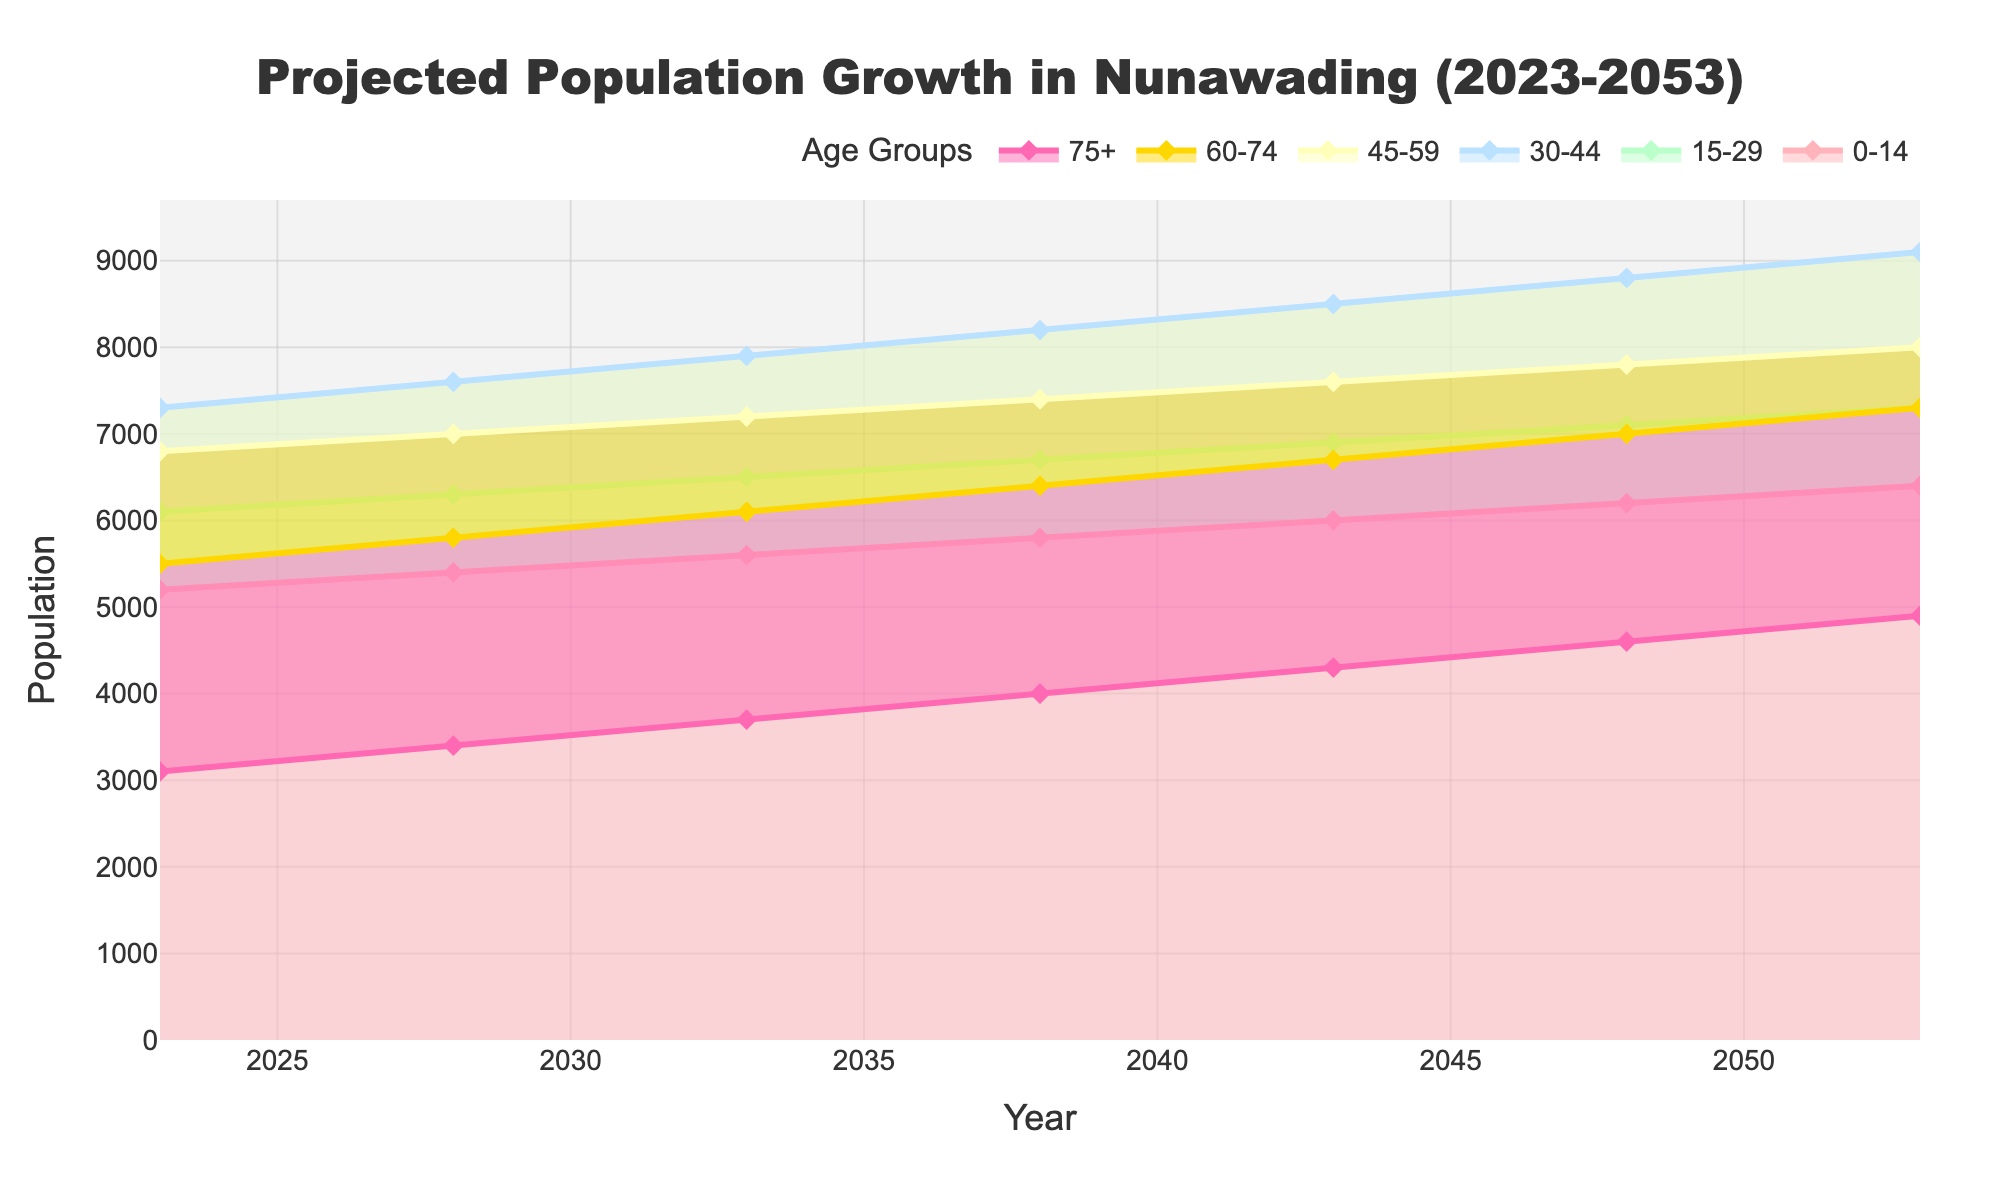What is the title of the chart? The title is displayed prominently at the top center of the chart. It describes the purpose and scope of the data presented.
Answer: Projected Population Growth in Nunawading (2023-2053) How many age groups are represented in the chart? The chart legend lists each age group, and there are six distinct colors used in the chart, each corresponding to a different age group.
Answer: 6 Which age group has the smallest population projected in 2023? By looking at the starting values at the leftmost part of the chart in 2023, the age group "75+" has the smallest population, as represented by the lowest line.
Answer: 75+ What is the projected population of the 30-44 age group in 2038? Find the data point on the curve for the 30-44 age group at the year 2038, which is situated on the x-axis.
Answer: 8200 How does the population of the 0-14 age group change from 2023 to 2053? Subtract the value at 2023 from the value at 2053 for the 0-14 age group to find the difference.
Answer: Increase of 1200 Which age group shows the highest growth rate between 2023 and 2053? Compare the difference between 2053 and 2023 values for all age groups and find the one with the largest increase.
Answer: 75+ In which year is the population of the 45-59 age group projected to reach 7600? Locate the year on the x-axis where the value for the 45-59 age group reaches 7600.
Answer: 2043 What is the combined projected population for the age groups 0-14 and 30-44 in the year 2053? Add the values for the 0-14 and 30-44 age groups at the year 2053.
Answer: 15500 Between which consecutive years is the smallest increase in population projected for the 60-74 age group? Calculate the increment for each consecutive pair of years in the 60-74 age group and find the pair with the smallest increment.
Answer: 2053 to 2048 Which age group is expected to have a population closest to 7000 in 2048? Look at the values projected for each age group in 2048 and find the one closest to 7000.
Answer: 60-74 